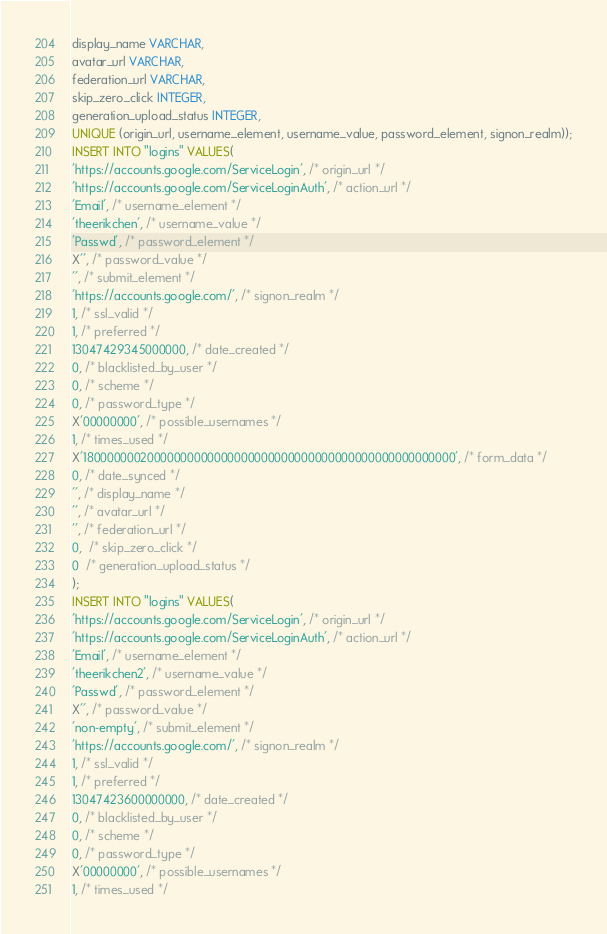Convert code to text. <code><loc_0><loc_0><loc_500><loc_500><_SQL_>display_name VARCHAR,
avatar_url VARCHAR,
federation_url VARCHAR,
skip_zero_click INTEGER,
generation_upload_status INTEGER,
UNIQUE (origin_url, username_element, username_value, password_element, signon_realm));
INSERT INTO "logins" VALUES(
'https://accounts.google.com/ServiceLogin', /* origin_url */
'https://accounts.google.com/ServiceLoginAuth', /* action_url */
'Email', /* username_element */
'theerikchen', /* username_value */
'Passwd', /* password_element */
X'', /* password_value */
'', /* submit_element */
'https://accounts.google.com/', /* signon_realm */
1, /* ssl_valid */
1, /* preferred */
13047429345000000, /* date_created */
0, /* blacklisted_by_user */
0, /* scheme */
0, /* password_type */
X'00000000', /* possible_usernames */
1, /* times_used */
X'18000000020000000000000000000000000000000000000000000000', /* form_data */
0, /* date_synced */
'', /* display_name */
'', /* avatar_url */
'', /* federation_url */
0,  /* skip_zero_click */
0  /* generation_upload_status */
);
INSERT INTO "logins" VALUES(
'https://accounts.google.com/ServiceLogin', /* origin_url */
'https://accounts.google.com/ServiceLoginAuth', /* action_url */
'Email', /* username_element */
'theerikchen2', /* username_value */
'Passwd', /* password_element */
X'', /* password_value */
'non-empty', /* submit_element */
'https://accounts.google.com/', /* signon_realm */
1, /* ssl_valid */
1, /* preferred */
13047423600000000, /* date_created */
0, /* blacklisted_by_user */
0, /* scheme */
0, /* password_type */
X'00000000', /* possible_usernames */
1, /* times_used */</code> 